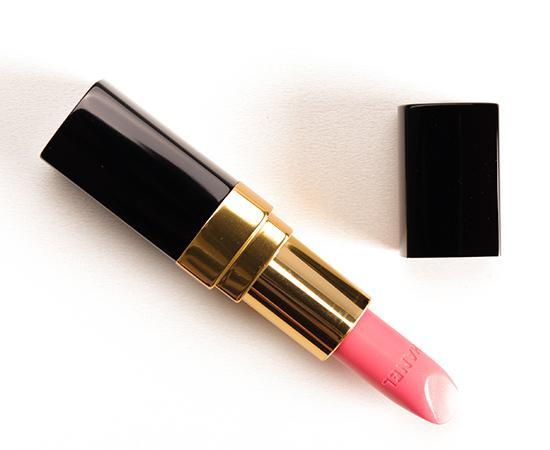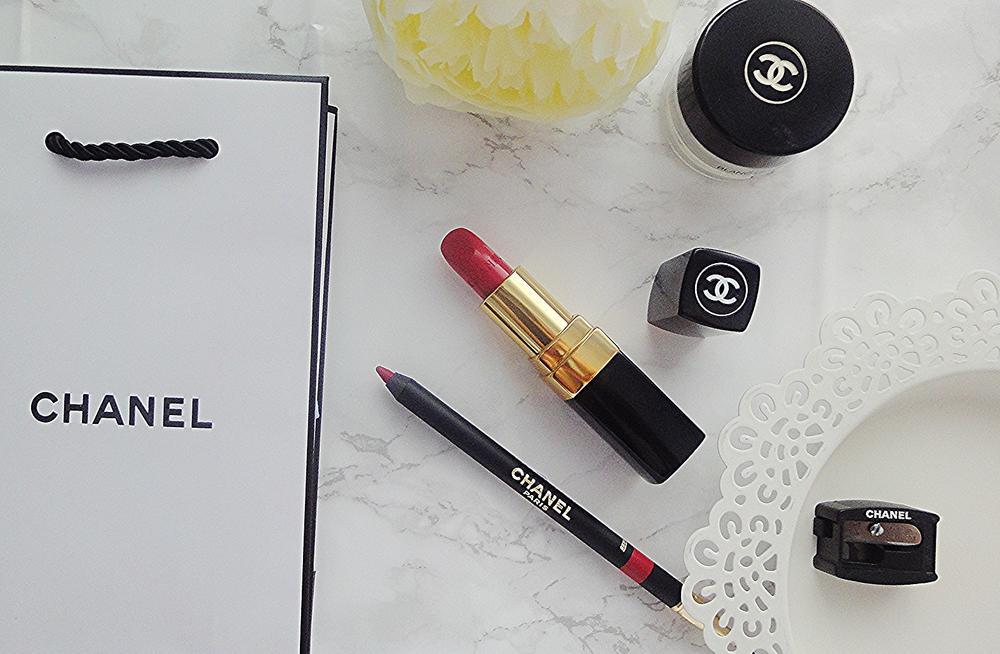The first image is the image on the left, the second image is the image on the right. Assess this claim about the two images: "There is one tube of lipstick in each of the images.". Correct or not? Answer yes or no. Yes. The first image is the image on the left, the second image is the image on the right. Evaluate the accuracy of this statement regarding the images: "An image with a lip pencil and lipstick includes a creamy colored flower.". Is it true? Answer yes or no. Yes. 